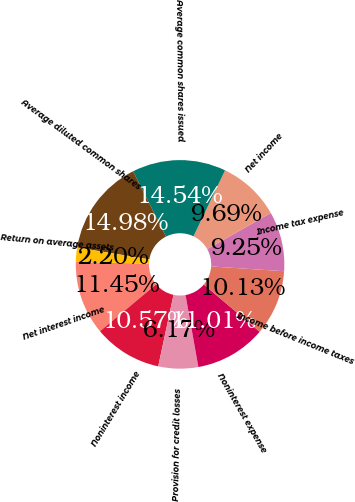Convert chart to OTSL. <chart><loc_0><loc_0><loc_500><loc_500><pie_chart><fcel>Net interest income<fcel>Noninterest income<fcel>Provision for credit losses<fcel>Noninterest expense<fcel>Income before income taxes<fcel>Income tax expense<fcel>Net income<fcel>Average common shares issued<fcel>Average diluted common shares<fcel>Return on average assets<nl><fcel>11.45%<fcel>10.57%<fcel>6.17%<fcel>11.01%<fcel>10.13%<fcel>9.25%<fcel>9.69%<fcel>14.54%<fcel>14.98%<fcel>2.2%<nl></chart> 